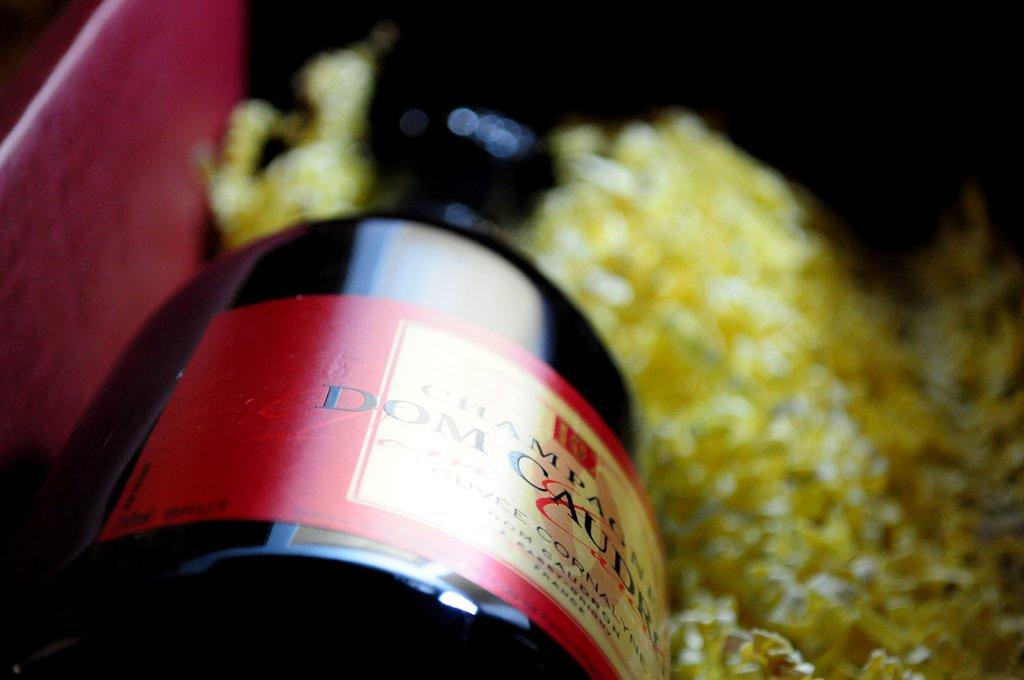<image>
Summarize the visual content of the image. A bottle of a champagne in a dark bottle is in a red box. 